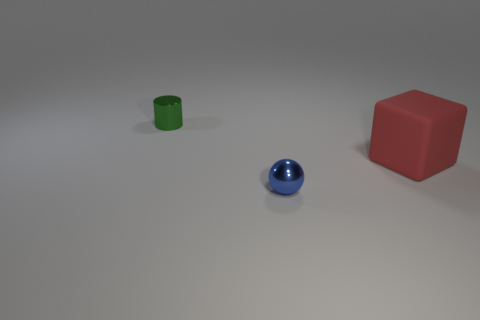Add 1 cubes. How many objects exist? 4 Subtract 0 gray spheres. How many objects are left? 3 Subtract all spheres. How many objects are left? 2 Subtract all big green matte cubes. Subtract all red matte blocks. How many objects are left? 2 Add 1 balls. How many balls are left? 2 Add 1 small green objects. How many small green objects exist? 2 